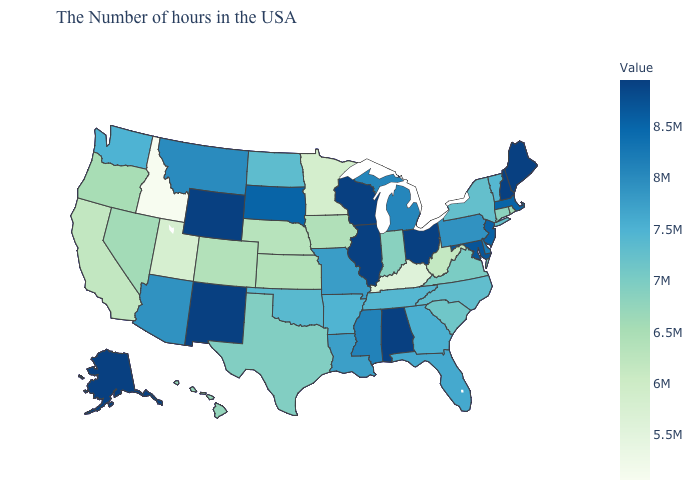Does the map have missing data?
Be succinct. No. Does Nevada have the highest value in the USA?
Be succinct. No. Does Connecticut have the highest value in the Northeast?
Write a very short answer. No. Does the map have missing data?
Concise answer only. No. Which states have the lowest value in the Northeast?
Concise answer only. Rhode Island. Does New Hampshire have the highest value in the Northeast?
Short answer required. Yes. Does Ohio have the lowest value in the USA?
Quick response, please. No. Is the legend a continuous bar?
Write a very short answer. Yes. Does West Virginia have a lower value than Idaho?
Give a very brief answer. No. 